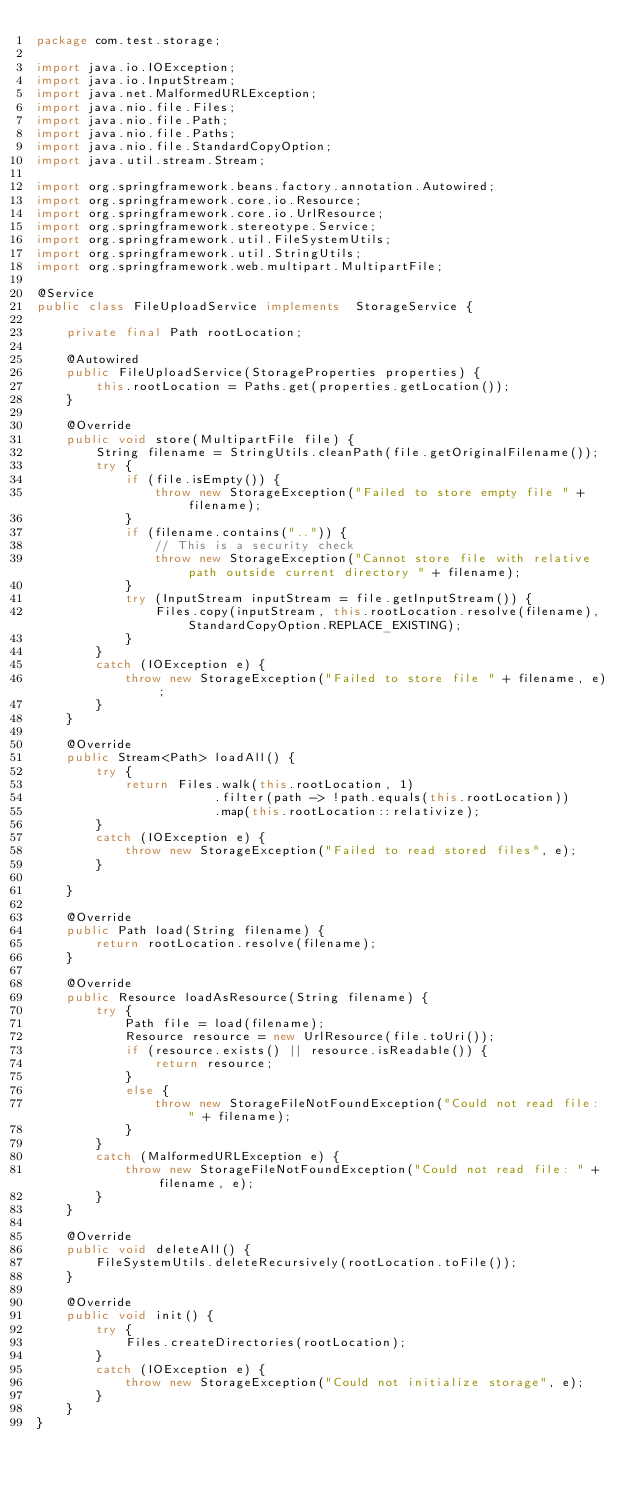Convert code to text. <code><loc_0><loc_0><loc_500><loc_500><_Java_>package com.test.storage;

import java.io.IOException;
import java.io.InputStream;
import java.net.MalformedURLException;
import java.nio.file.Files;
import java.nio.file.Path;
import java.nio.file.Paths;
import java.nio.file.StandardCopyOption;
import java.util.stream.Stream;

import org.springframework.beans.factory.annotation.Autowired;
import org.springframework.core.io.Resource;
import org.springframework.core.io.UrlResource;
import org.springframework.stereotype.Service;
import org.springframework.util.FileSystemUtils;
import org.springframework.util.StringUtils;
import org.springframework.web.multipart.MultipartFile;

@Service
public class FileUploadService implements  StorageService {

    private final Path rootLocation;

    @Autowired
    public FileUploadService(StorageProperties properties) {
        this.rootLocation = Paths.get(properties.getLocation());
    }

    @Override
    public void store(MultipartFile file) {
        String filename = StringUtils.cleanPath(file.getOriginalFilename());
        try {
            if (file.isEmpty()) {
                throw new StorageException("Failed to store empty file " + filename);
            }
            if (filename.contains("..")) {
                // This is a security check
                throw new StorageException("Cannot store file with relative path outside current directory " + filename);
            }
            try (InputStream inputStream = file.getInputStream()) {
                Files.copy(inputStream, this.rootLocation.resolve(filename), StandardCopyOption.REPLACE_EXISTING);
            }
        }
        catch (IOException e) {
            throw new StorageException("Failed to store file " + filename, e);
        }
    }

    @Override
    public Stream<Path> loadAll() {
        try {
            return Files.walk(this.rootLocation, 1)
                        .filter(path -> !path.equals(this.rootLocation))
                        .map(this.rootLocation::relativize);
        }
        catch (IOException e) {
            throw new StorageException("Failed to read stored files", e);
        }

    }

    @Override
    public Path load(String filename) {
        return rootLocation.resolve(filename);
    }

    @Override
    public Resource loadAsResource(String filename) {
        try {
            Path file = load(filename);
            Resource resource = new UrlResource(file.toUri());
            if (resource.exists() || resource.isReadable()) {
                return resource;
            }
            else {
                throw new StorageFileNotFoundException("Could not read file: " + filename);
            }
        }
        catch (MalformedURLException e) {
            throw new StorageFileNotFoundException("Could not read file: " + filename, e);
        }
    }

    @Override
    public void deleteAll() {
        FileSystemUtils.deleteRecursively(rootLocation.toFile());
    }

    @Override
    public void init() {
        try {
            Files.createDirectories(rootLocation);
        }
        catch (IOException e) {
            throw new StorageException("Could not initialize storage", e);
        }
    }
}
</code> 